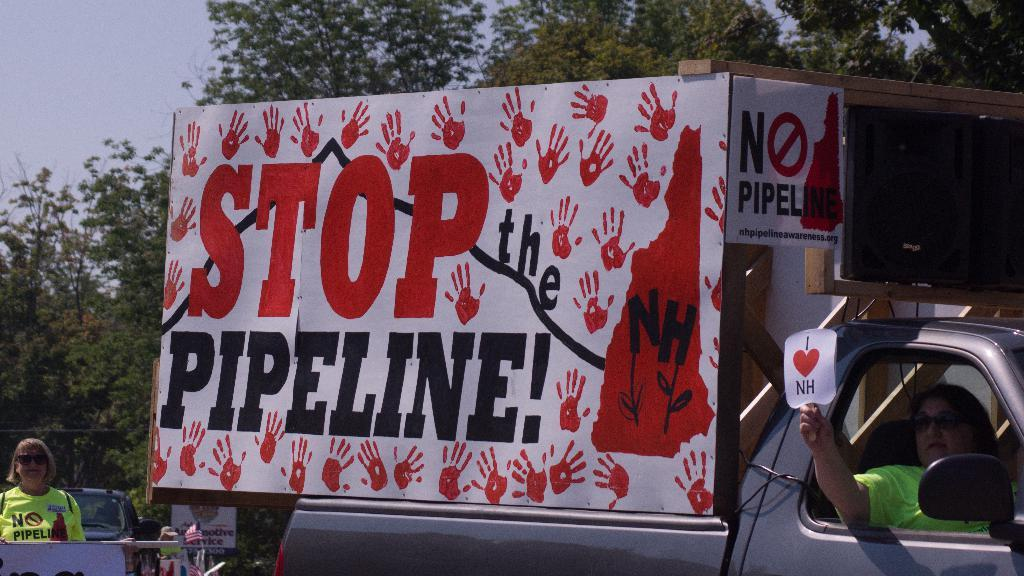What can be seen in the foreground of the picture? In the foreground of the picture, there are vehicles, people, placards, and boards. What type of objects are the people interacting with in the foreground? The people in the foreground are interacting with placards and boards. What is visible in the background of the picture? In the background of the picture, there are trees. Can you tell me how many heads of lettuce are on the placards in the image? There is no lettuce present on the placards in the image. Are there any planes visible in the background of the image? There are no planes visible in the image; only trees are present in the background. 